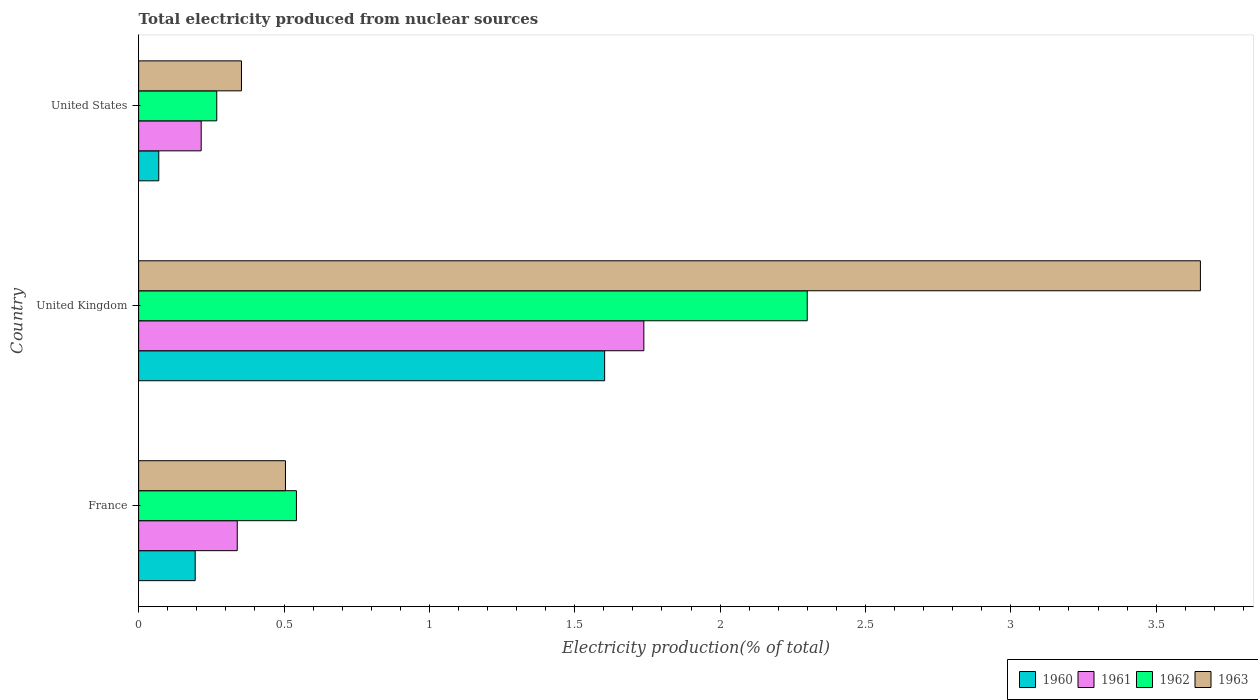How many different coloured bars are there?
Keep it short and to the point. 4. How many groups of bars are there?
Provide a succinct answer. 3. Are the number of bars per tick equal to the number of legend labels?
Provide a short and direct response. Yes. How many bars are there on the 2nd tick from the top?
Provide a succinct answer. 4. In how many cases, is the number of bars for a given country not equal to the number of legend labels?
Offer a very short reply. 0. What is the total electricity produced in 1961 in United States?
Provide a short and direct response. 0.22. Across all countries, what is the maximum total electricity produced in 1960?
Keep it short and to the point. 1.6. Across all countries, what is the minimum total electricity produced in 1961?
Make the answer very short. 0.22. In which country was the total electricity produced in 1960 maximum?
Offer a very short reply. United Kingdom. In which country was the total electricity produced in 1961 minimum?
Make the answer very short. United States. What is the total total electricity produced in 1961 in the graph?
Give a very brief answer. 2.29. What is the difference between the total electricity produced in 1963 in United Kingdom and that in United States?
Keep it short and to the point. 3.3. What is the difference between the total electricity produced in 1963 in United States and the total electricity produced in 1962 in France?
Provide a succinct answer. -0.19. What is the average total electricity produced in 1961 per country?
Your answer should be compact. 0.76. What is the difference between the total electricity produced in 1962 and total electricity produced in 1961 in United Kingdom?
Offer a very short reply. 0.56. What is the ratio of the total electricity produced in 1962 in United Kingdom to that in United States?
Offer a terse response. 8.56. Is the total electricity produced in 1961 in France less than that in United States?
Your answer should be compact. No. Is the difference between the total electricity produced in 1962 in United Kingdom and United States greater than the difference between the total electricity produced in 1961 in United Kingdom and United States?
Your answer should be compact. Yes. What is the difference between the highest and the second highest total electricity produced in 1960?
Offer a very short reply. 1.41. What is the difference between the highest and the lowest total electricity produced in 1963?
Ensure brevity in your answer.  3.3. In how many countries, is the total electricity produced in 1963 greater than the average total electricity produced in 1963 taken over all countries?
Make the answer very short. 1. Is it the case that in every country, the sum of the total electricity produced in 1962 and total electricity produced in 1963 is greater than the sum of total electricity produced in 1961 and total electricity produced in 1960?
Offer a very short reply. No. Is it the case that in every country, the sum of the total electricity produced in 1961 and total electricity produced in 1963 is greater than the total electricity produced in 1960?
Ensure brevity in your answer.  Yes. How many bars are there?
Give a very brief answer. 12. Are all the bars in the graph horizontal?
Your answer should be compact. Yes. What is the difference between two consecutive major ticks on the X-axis?
Your answer should be compact. 0.5. Are the values on the major ticks of X-axis written in scientific E-notation?
Offer a terse response. No. What is the title of the graph?
Provide a short and direct response. Total electricity produced from nuclear sources. What is the Electricity production(% of total) of 1960 in France?
Provide a succinct answer. 0.19. What is the Electricity production(% of total) of 1961 in France?
Offer a terse response. 0.34. What is the Electricity production(% of total) in 1962 in France?
Your answer should be very brief. 0.54. What is the Electricity production(% of total) in 1963 in France?
Ensure brevity in your answer.  0.51. What is the Electricity production(% of total) of 1960 in United Kingdom?
Your answer should be very brief. 1.6. What is the Electricity production(% of total) of 1961 in United Kingdom?
Offer a terse response. 1.74. What is the Electricity production(% of total) of 1962 in United Kingdom?
Provide a succinct answer. 2.3. What is the Electricity production(% of total) of 1963 in United Kingdom?
Offer a terse response. 3.65. What is the Electricity production(% of total) in 1960 in United States?
Give a very brief answer. 0.07. What is the Electricity production(% of total) in 1961 in United States?
Ensure brevity in your answer.  0.22. What is the Electricity production(% of total) in 1962 in United States?
Keep it short and to the point. 0.27. What is the Electricity production(% of total) of 1963 in United States?
Provide a succinct answer. 0.35. Across all countries, what is the maximum Electricity production(% of total) of 1960?
Keep it short and to the point. 1.6. Across all countries, what is the maximum Electricity production(% of total) of 1961?
Make the answer very short. 1.74. Across all countries, what is the maximum Electricity production(% of total) of 1962?
Offer a very short reply. 2.3. Across all countries, what is the maximum Electricity production(% of total) in 1963?
Give a very brief answer. 3.65. Across all countries, what is the minimum Electricity production(% of total) of 1960?
Provide a succinct answer. 0.07. Across all countries, what is the minimum Electricity production(% of total) in 1961?
Offer a very short reply. 0.22. Across all countries, what is the minimum Electricity production(% of total) in 1962?
Provide a short and direct response. 0.27. Across all countries, what is the minimum Electricity production(% of total) of 1963?
Ensure brevity in your answer.  0.35. What is the total Electricity production(% of total) in 1960 in the graph?
Provide a short and direct response. 1.87. What is the total Electricity production(% of total) in 1961 in the graph?
Give a very brief answer. 2.29. What is the total Electricity production(% of total) of 1962 in the graph?
Provide a short and direct response. 3.11. What is the total Electricity production(% of total) of 1963 in the graph?
Keep it short and to the point. 4.51. What is the difference between the Electricity production(% of total) of 1960 in France and that in United Kingdom?
Your answer should be very brief. -1.41. What is the difference between the Electricity production(% of total) in 1961 in France and that in United Kingdom?
Keep it short and to the point. -1.4. What is the difference between the Electricity production(% of total) in 1962 in France and that in United Kingdom?
Give a very brief answer. -1.76. What is the difference between the Electricity production(% of total) of 1963 in France and that in United Kingdom?
Your response must be concise. -3.15. What is the difference between the Electricity production(% of total) in 1960 in France and that in United States?
Your answer should be very brief. 0.13. What is the difference between the Electricity production(% of total) in 1961 in France and that in United States?
Keep it short and to the point. 0.12. What is the difference between the Electricity production(% of total) of 1962 in France and that in United States?
Your answer should be compact. 0.27. What is the difference between the Electricity production(% of total) of 1963 in France and that in United States?
Give a very brief answer. 0.15. What is the difference between the Electricity production(% of total) of 1960 in United Kingdom and that in United States?
Provide a short and direct response. 1.53. What is the difference between the Electricity production(% of total) in 1961 in United Kingdom and that in United States?
Offer a very short reply. 1.52. What is the difference between the Electricity production(% of total) in 1962 in United Kingdom and that in United States?
Make the answer very short. 2.03. What is the difference between the Electricity production(% of total) in 1963 in United Kingdom and that in United States?
Provide a short and direct response. 3.3. What is the difference between the Electricity production(% of total) in 1960 in France and the Electricity production(% of total) in 1961 in United Kingdom?
Your response must be concise. -1.54. What is the difference between the Electricity production(% of total) of 1960 in France and the Electricity production(% of total) of 1962 in United Kingdom?
Provide a short and direct response. -2.11. What is the difference between the Electricity production(% of total) of 1960 in France and the Electricity production(% of total) of 1963 in United Kingdom?
Your answer should be very brief. -3.46. What is the difference between the Electricity production(% of total) of 1961 in France and the Electricity production(% of total) of 1962 in United Kingdom?
Your answer should be compact. -1.96. What is the difference between the Electricity production(% of total) in 1961 in France and the Electricity production(% of total) in 1963 in United Kingdom?
Provide a succinct answer. -3.31. What is the difference between the Electricity production(% of total) in 1962 in France and the Electricity production(% of total) in 1963 in United Kingdom?
Ensure brevity in your answer.  -3.11. What is the difference between the Electricity production(% of total) of 1960 in France and the Electricity production(% of total) of 1961 in United States?
Provide a short and direct response. -0.02. What is the difference between the Electricity production(% of total) of 1960 in France and the Electricity production(% of total) of 1962 in United States?
Keep it short and to the point. -0.07. What is the difference between the Electricity production(% of total) of 1960 in France and the Electricity production(% of total) of 1963 in United States?
Offer a very short reply. -0.16. What is the difference between the Electricity production(% of total) of 1961 in France and the Electricity production(% of total) of 1962 in United States?
Keep it short and to the point. 0.07. What is the difference between the Electricity production(% of total) of 1961 in France and the Electricity production(% of total) of 1963 in United States?
Give a very brief answer. -0.01. What is the difference between the Electricity production(% of total) in 1962 in France and the Electricity production(% of total) in 1963 in United States?
Provide a short and direct response. 0.19. What is the difference between the Electricity production(% of total) of 1960 in United Kingdom and the Electricity production(% of total) of 1961 in United States?
Ensure brevity in your answer.  1.39. What is the difference between the Electricity production(% of total) of 1960 in United Kingdom and the Electricity production(% of total) of 1962 in United States?
Provide a succinct answer. 1.33. What is the difference between the Electricity production(% of total) in 1960 in United Kingdom and the Electricity production(% of total) in 1963 in United States?
Your answer should be compact. 1.25. What is the difference between the Electricity production(% of total) of 1961 in United Kingdom and the Electricity production(% of total) of 1962 in United States?
Your answer should be very brief. 1.47. What is the difference between the Electricity production(% of total) in 1961 in United Kingdom and the Electricity production(% of total) in 1963 in United States?
Keep it short and to the point. 1.38. What is the difference between the Electricity production(% of total) in 1962 in United Kingdom and the Electricity production(% of total) in 1963 in United States?
Provide a short and direct response. 1.95. What is the average Electricity production(% of total) of 1960 per country?
Offer a terse response. 0.62. What is the average Electricity production(% of total) in 1961 per country?
Keep it short and to the point. 0.76. What is the average Electricity production(% of total) of 1963 per country?
Provide a succinct answer. 1.5. What is the difference between the Electricity production(% of total) in 1960 and Electricity production(% of total) in 1961 in France?
Keep it short and to the point. -0.14. What is the difference between the Electricity production(% of total) in 1960 and Electricity production(% of total) in 1962 in France?
Give a very brief answer. -0.35. What is the difference between the Electricity production(% of total) of 1960 and Electricity production(% of total) of 1963 in France?
Ensure brevity in your answer.  -0.31. What is the difference between the Electricity production(% of total) in 1961 and Electricity production(% of total) in 1962 in France?
Offer a terse response. -0.2. What is the difference between the Electricity production(% of total) of 1961 and Electricity production(% of total) of 1963 in France?
Give a very brief answer. -0.17. What is the difference between the Electricity production(% of total) in 1962 and Electricity production(% of total) in 1963 in France?
Your answer should be compact. 0.04. What is the difference between the Electricity production(% of total) of 1960 and Electricity production(% of total) of 1961 in United Kingdom?
Offer a terse response. -0.13. What is the difference between the Electricity production(% of total) in 1960 and Electricity production(% of total) in 1962 in United Kingdom?
Your response must be concise. -0.7. What is the difference between the Electricity production(% of total) of 1960 and Electricity production(% of total) of 1963 in United Kingdom?
Give a very brief answer. -2.05. What is the difference between the Electricity production(% of total) of 1961 and Electricity production(% of total) of 1962 in United Kingdom?
Offer a terse response. -0.56. What is the difference between the Electricity production(% of total) in 1961 and Electricity production(% of total) in 1963 in United Kingdom?
Ensure brevity in your answer.  -1.91. What is the difference between the Electricity production(% of total) in 1962 and Electricity production(% of total) in 1963 in United Kingdom?
Offer a very short reply. -1.35. What is the difference between the Electricity production(% of total) of 1960 and Electricity production(% of total) of 1961 in United States?
Offer a terse response. -0.15. What is the difference between the Electricity production(% of total) of 1960 and Electricity production(% of total) of 1962 in United States?
Your response must be concise. -0.2. What is the difference between the Electricity production(% of total) in 1960 and Electricity production(% of total) in 1963 in United States?
Give a very brief answer. -0.28. What is the difference between the Electricity production(% of total) in 1961 and Electricity production(% of total) in 1962 in United States?
Give a very brief answer. -0.05. What is the difference between the Electricity production(% of total) of 1961 and Electricity production(% of total) of 1963 in United States?
Ensure brevity in your answer.  -0.14. What is the difference between the Electricity production(% of total) in 1962 and Electricity production(% of total) in 1963 in United States?
Offer a terse response. -0.09. What is the ratio of the Electricity production(% of total) in 1960 in France to that in United Kingdom?
Your response must be concise. 0.12. What is the ratio of the Electricity production(% of total) of 1961 in France to that in United Kingdom?
Your answer should be compact. 0.2. What is the ratio of the Electricity production(% of total) of 1962 in France to that in United Kingdom?
Your response must be concise. 0.24. What is the ratio of the Electricity production(% of total) of 1963 in France to that in United Kingdom?
Your answer should be very brief. 0.14. What is the ratio of the Electricity production(% of total) in 1960 in France to that in United States?
Keep it short and to the point. 2.81. What is the ratio of the Electricity production(% of total) of 1961 in France to that in United States?
Provide a succinct answer. 1.58. What is the ratio of the Electricity production(% of total) of 1962 in France to that in United States?
Your answer should be very brief. 2.02. What is the ratio of the Electricity production(% of total) of 1963 in France to that in United States?
Provide a short and direct response. 1.43. What is the ratio of the Electricity production(% of total) of 1960 in United Kingdom to that in United States?
Keep it short and to the point. 23.14. What is the ratio of the Electricity production(% of total) in 1961 in United Kingdom to that in United States?
Your response must be concise. 8.08. What is the ratio of the Electricity production(% of total) of 1962 in United Kingdom to that in United States?
Your response must be concise. 8.56. What is the ratio of the Electricity production(% of total) in 1963 in United Kingdom to that in United States?
Keep it short and to the point. 10.32. What is the difference between the highest and the second highest Electricity production(% of total) of 1960?
Make the answer very short. 1.41. What is the difference between the highest and the second highest Electricity production(% of total) of 1961?
Make the answer very short. 1.4. What is the difference between the highest and the second highest Electricity production(% of total) in 1962?
Your response must be concise. 1.76. What is the difference between the highest and the second highest Electricity production(% of total) of 1963?
Give a very brief answer. 3.15. What is the difference between the highest and the lowest Electricity production(% of total) of 1960?
Make the answer very short. 1.53. What is the difference between the highest and the lowest Electricity production(% of total) in 1961?
Your answer should be very brief. 1.52. What is the difference between the highest and the lowest Electricity production(% of total) of 1962?
Ensure brevity in your answer.  2.03. What is the difference between the highest and the lowest Electricity production(% of total) in 1963?
Provide a short and direct response. 3.3. 